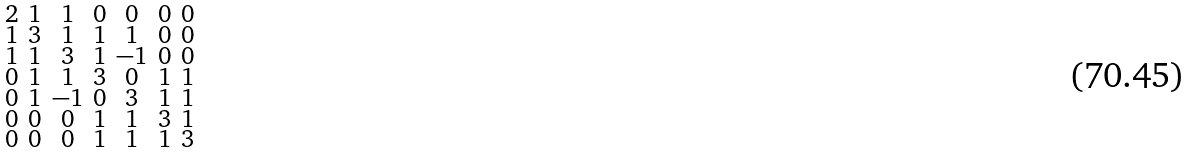Convert formula to latex. <formula><loc_0><loc_0><loc_500><loc_500>\begin{smallmatrix} 2 & 1 & 1 & 0 & 0 & 0 & 0 \\ 1 & 3 & 1 & 1 & 1 & 0 & 0 \\ 1 & 1 & 3 & 1 & - 1 & 0 & 0 \\ 0 & 1 & 1 & 3 & 0 & 1 & 1 \\ 0 & 1 & - 1 & 0 & 3 & 1 & 1 \\ 0 & 0 & 0 & 1 & 1 & 3 & 1 \\ 0 & 0 & 0 & 1 & 1 & 1 & 3 \end{smallmatrix}</formula> 